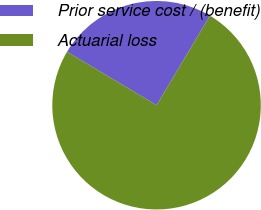Convert chart to OTSL. <chart><loc_0><loc_0><loc_500><loc_500><pie_chart><fcel>Prior service cost / (benefit)<fcel>Actuarial loss<nl><fcel>25.0%<fcel>75.0%<nl></chart> 